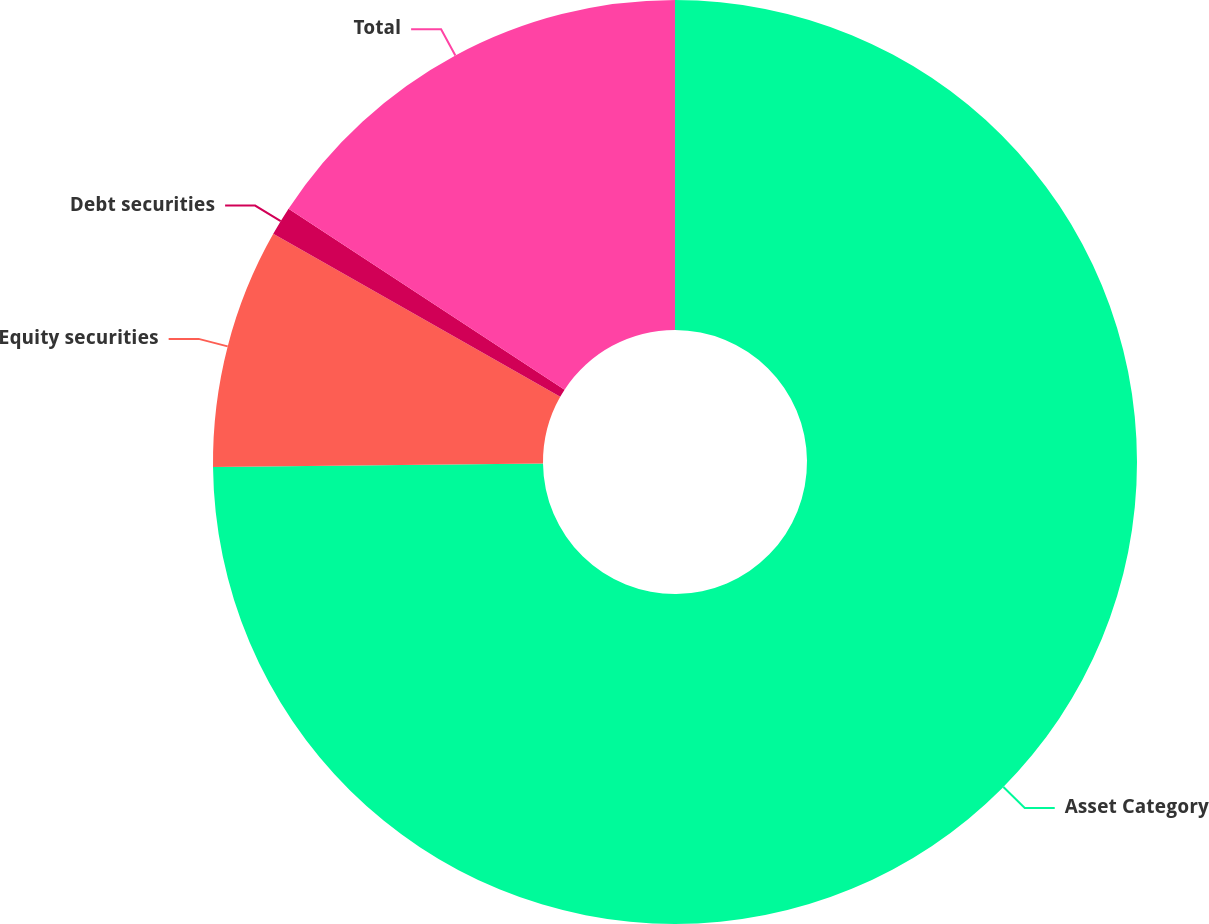Convert chart to OTSL. <chart><loc_0><loc_0><loc_500><loc_500><pie_chart><fcel>Asset Category<fcel>Equity securities<fcel>Debt securities<fcel>Total<nl><fcel>74.83%<fcel>8.39%<fcel>1.01%<fcel>15.77%<nl></chart> 